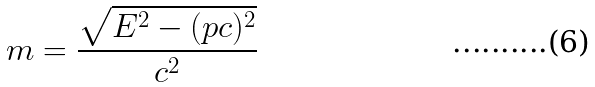<formula> <loc_0><loc_0><loc_500><loc_500>m = \frac { \sqrt { E ^ { 2 } - ( p c ) ^ { 2 } } } { c ^ { 2 } }</formula> 